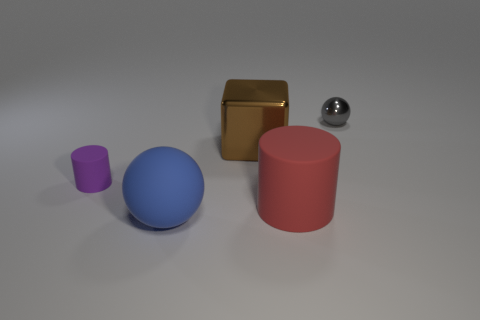Add 5 large cyan objects. How many objects exist? 10 Subtract all cylinders. How many objects are left? 3 Add 2 spheres. How many spheres are left? 4 Add 5 gray shiny things. How many gray shiny things exist? 6 Subtract 1 purple cylinders. How many objects are left? 4 Subtract all blue matte things. Subtract all small brown balls. How many objects are left? 4 